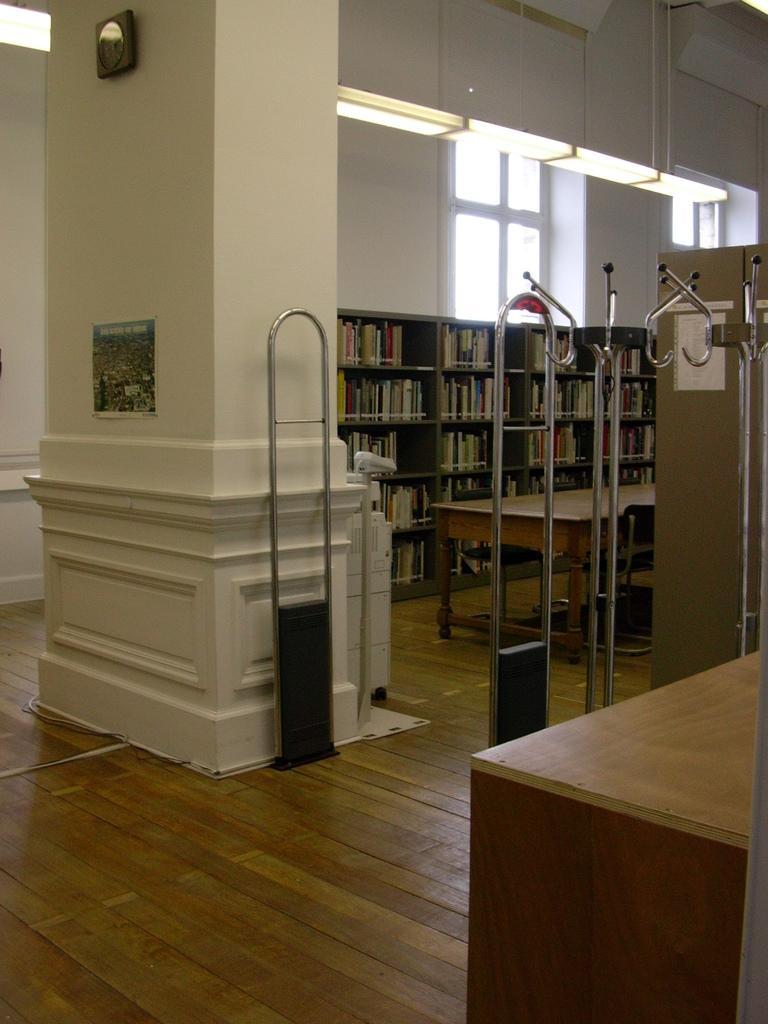How would you summarize this image in a sentence or two? In this image there is a wooden floor, on the bottom right there is a table, in the background there is a pillar, shelves, in that shelves there are books and a table and there are iron poles, at the top there is a ceiling and there is a wall, for that wall there are windows. 